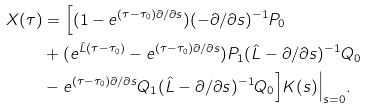<formula> <loc_0><loc_0><loc_500><loc_500>X ( \tau ) & = \Big [ ( 1 - e ^ { ( \tau - \tau _ { 0 } ) \partial / \partial s } ) ( - \partial / \partial s ) ^ { - 1 } P _ { 0 } \\ & + ( e ^ { \hat { L } ( \tau - \tau _ { 0 } ) } - e ^ { ( \tau - \tau _ { 0 } ) \partial / \partial s } ) P _ { 1 } ( \hat { L } - \partial / \partial s ) ^ { - 1 } Q _ { 0 } \\ & - e ^ { ( \tau - \tau _ { 0 } ) \partial / \partial s } Q _ { 1 } ( \hat { L } - \partial / \partial s ) ^ { - 1 } Q _ { 0 } \Big ] K ( s ) \Big | _ { s = 0 } .</formula> 